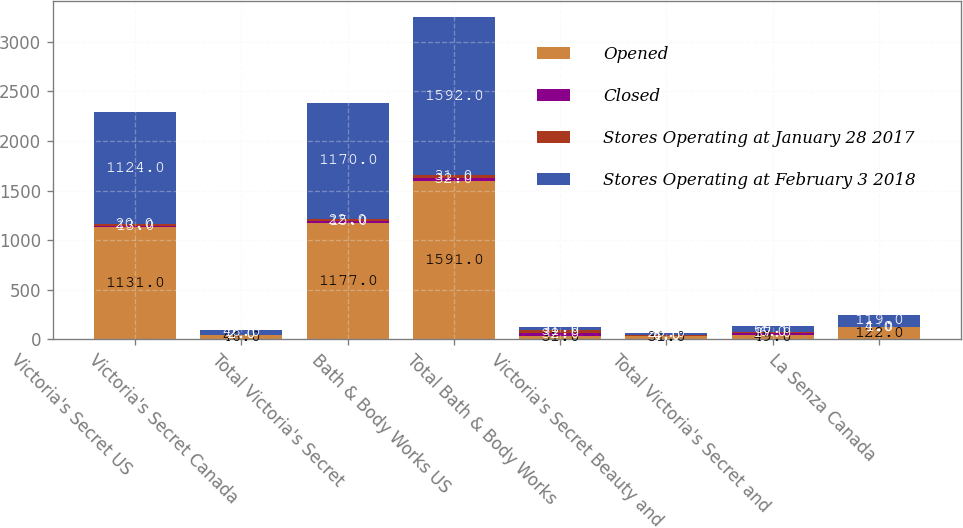Convert chart. <chart><loc_0><loc_0><loc_500><loc_500><stacked_bar_chart><ecel><fcel>Victoria's Secret US<fcel>Victoria's Secret Canada<fcel>Total Victoria's Secret<fcel>Bath & Body Works US<fcel>Total Bath & Body Works<fcel>Victoria's Secret Beauty and<fcel>Total Victoria's Secret and<fcel>La Senza Canada<nl><fcel>Opened<fcel>1131<fcel>46<fcel>1177<fcel>1591<fcel>31<fcel>31<fcel>49<fcel>122<nl><fcel>Closed<fcel>13<fcel>2<fcel>15<fcel>32<fcel>32<fcel>4<fcel>17<fcel>1<nl><fcel>Stores Operating at January 28 2017<fcel>20<fcel>2<fcel>22<fcel>31<fcel>31<fcel>6<fcel>6<fcel>4<nl><fcel>Stores Operating at February 3 2018<fcel>1124<fcel>46<fcel>1170<fcel>1592<fcel>31<fcel>29<fcel>60<fcel>119<nl></chart> 